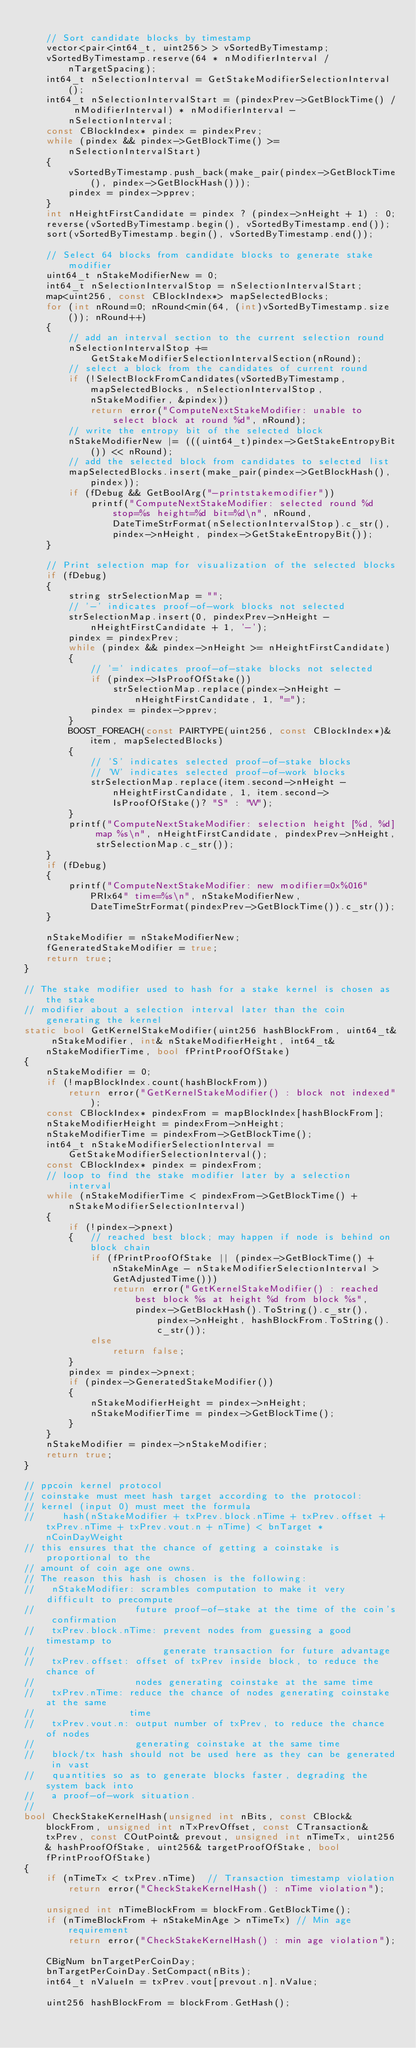<code> <loc_0><loc_0><loc_500><loc_500><_C++_>
    // Sort candidate blocks by timestamp
    vector<pair<int64_t, uint256> > vSortedByTimestamp;
    vSortedByTimestamp.reserve(64 * nModifierInterval / nTargetSpacing);
    int64_t nSelectionInterval = GetStakeModifierSelectionInterval();
    int64_t nSelectionIntervalStart = (pindexPrev->GetBlockTime() / nModifierInterval) * nModifierInterval - nSelectionInterval;
    const CBlockIndex* pindex = pindexPrev;
    while (pindex && pindex->GetBlockTime() >= nSelectionIntervalStart)
    {
        vSortedByTimestamp.push_back(make_pair(pindex->GetBlockTime(), pindex->GetBlockHash()));
        pindex = pindex->pprev;
    }
    int nHeightFirstCandidate = pindex ? (pindex->nHeight + 1) : 0;
    reverse(vSortedByTimestamp.begin(), vSortedByTimestamp.end());
    sort(vSortedByTimestamp.begin(), vSortedByTimestamp.end());

    // Select 64 blocks from candidate blocks to generate stake modifier
    uint64_t nStakeModifierNew = 0;
    int64_t nSelectionIntervalStop = nSelectionIntervalStart;
    map<uint256, const CBlockIndex*> mapSelectedBlocks;
    for (int nRound=0; nRound<min(64, (int)vSortedByTimestamp.size()); nRound++)
    {
        // add an interval section to the current selection round
        nSelectionIntervalStop += GetStakeModifierSelectionIntervalSection(nRound);
        // select a block from the candidates of current round
        if (!SelectBlockFromCandidates(vSortedByTimestamp, mapSelectedBlocks, nSelectionIntervalStop, nStakeModifier, &pindex))
            return error("ComputeNextStakeModifier: unable to select block at round %d", nRound);
        // write the entropy bit of the selected block
        nStakeModifierNew |= (((uint64_t)pindex->GetStakeEntropyBit()) << nRound);
        // add the selected block from candidates to selected list
        mapSelectedBlocks.insert(make_pair(pindex->GetBlockHash(), pindex));
        if (fDebug && GetBoolArg("-printstakemodifier"))
            printf("ComputeNextStakeModifier: selected round %d stop=%s height=%d bit=%d\n", nRound, DateTimeStrFormat(nSelectionIntervalStop).c_str(), pindex->nHeight, pindex->GetStakeEntropyBit());
    }

    // Print selection map for visualization of the selected blocks
    if (fDebug)
    {
        string strSelectionMap = "";
        // '-' indicates proof-of-work blocks not selected
        strSelectionMap.insert(0, pindexPrev->nHeight - nHeightFirstCandidate + 1, '-');
        pindex = pindexPrev;
        while (pindex && pindex->nHeight >= nHeightFirstCandidate)
        {
            // '=' indicates proof-of-stake blocks not selected
            if (pindex->IsProofOfStake())
                strSelectionMap.replace(pindex->nHeight - nHeightFirstCandidate, 1, "=");
            pindex = pindex->pprev;
        }
        BOOST_FOREACH(const PAIRTYPE(uint256, const CBlockIndex*)& item, mapSelectedBlocks)
        {
            // 'S' indicates selected proof-of-stake blocks
            // 'W' indicates selected proof-of-work blocks
            strSelectionMap.replace(item.second->nHeight - nHeightFirstCandidate, 1, item.second->IsProofOfStake()? "S" : "W");
        }
        printf("ComputeNextStakeModifier: selection height [%d, %d] map %s\n", nHeightFirstCandidate, pindexPrev->nHeight, strSelectionMap.c_str());
    }
    if (fDebug)
    {
        printf("ComputeNextStakeModifier: new modifier=0x%016" PRIx64" time=%s\n", nStakeModifierNew, DateTimeStrFormat(pindexPrev->GetBlockTime()).c_str());
    }

    nStakeModifier = nStakeModifierNew;
    fGeneratedStakeModifier = true;
    return true;
}

// The stake modifier used to hash for a stake kernel is chosen as the stake
// modifier about a selection interval later than the coin generating the kernel
static bool GetKernelStakeModifier(uint256 hashBlockFrom, uint64_t& nStakeModifier, int& nStakeModifierHeight, int64_t& nStakeModifierTime, bool fPrintProofOfStake)
{
    nStakeModifier = 0;
    if (!mapBlockIndex.count(hashBlockFrom))
        return error("GetKernelStakeModifier() : block not indexed");
    const CBlockIndex* pindexFrom = mapBlockIndex[hashBlockFrom];
    nStakeModifierHeight = pindexFrom->nHeight;
    nStakeModifierTime = pindexFrom->GetBlockTime();
    int64_t nStakeModifierSelectionInterval = GetStakeModifierSelectionInterval();
    const CBlockIndex* pindex = pindexFrom;
    // loop to find the stake modifier later by a selection interval
    while (nStakeModifierTime < pindexFrom->GetBlockTime() + nStakeModifierSelectionInterval)
    {
        if (!pindex->pnext)
        {   // reached best block; may happen if node is behind on block chain
            if (fPrintProofOfStake || (pindex->GetBlockTime() + nStakeMinAge - nStakeModifierSelectionInterval > GetAdjustedTime()))
                return error("GetKernelStakeModifier() : reached best block %s at height %d from block %s",
                    pindex->GetBlockHash().ToString().c_str(), pindex->nHeight, hashBlockFrom.ToString().c_str());
            else
                return false;
        }
        pindex = pindex->pnext;
        if (pindex->GeneratedStakeModifier())
        {
            nStakeModifierHeight = pindex->nHeight;
            nStakeModifierTime = pindex->GetBlockTime();
        }
    }
    nStakeModifier = pindex->nStakeModifier;
    return true;
}

// ppcoin kernel protocol
// coinstake must meet hash target according to the protocol:
// kernel (input 0) must meet the formula
//     hash(nStakeModifier + txPrev.block.nTime + txPrev.offset + txPrev.nTime + txPrev.vout.n + nTime) < bnTarget * nCoinDayWeight
// this ensures that the chance of getting a coinstake is proportional to the
// amount of coin age one owns.
// The reason this hash is chosen is the following:
//   nStakeModifier: scrambles computation to make it very difficult to precompute
//                  future proof-of-stake at the time of the coin's confirmation
//   txPrev.block.nTime: prevent nodes from guessing a good timestamp to
//                       generate transaction for future advantage
//   txPrev.offset: offset of txPrev inside block, to reduce the chance of
//                  nodes generating coinstake at the same time
//   txPrev.nTime: reduce the chance of nodes generating coinstake at the same
//                 time
//   txPrev.vout.n: output number of txPrev, to reduce the chance of nodes
//                  generating coinstake at the same time
//   block/tx hash should not be used here as they can be generated in vast
//   quantities so as to generate blocks faster, degrading the system back into
//   a proof-of-work situation.
//
bool CheckStakeKernelHash(unsigned int nBits, const CBlock& blockFrom, unsigned int nTxPrevOffset, const CTransaction& txPrev, const COutPoint& prevout, unsigned int nTimeTx, uint256& hashProofOfStake, uint256& targetProofOfStake, bool fPrintProofOfStake)
{
    if (nTimeTx < txPrev.nTime)  // Transaction timestamp violation
        return error("CheckStakeKernelHash() : nTime violation");

    unsigned int nTimeBlockFrom = blockFrom.GetBlockTime();
    if (nTimeBlockFrom + nStakeMinAge > nTimeTx) // Min age requirement
        return error("CheckStakeKernelHash() : min age violation");

    CBigNum bnTargetPerCoinDay;
    bnTargetPerCoinDay.SetCompact(nBits);
    int64_t nValueIn = txPrev.vout[prevout.n].nValue;

    uint256 hashBlockFrom = blockFrom.GetHash();
</code> 